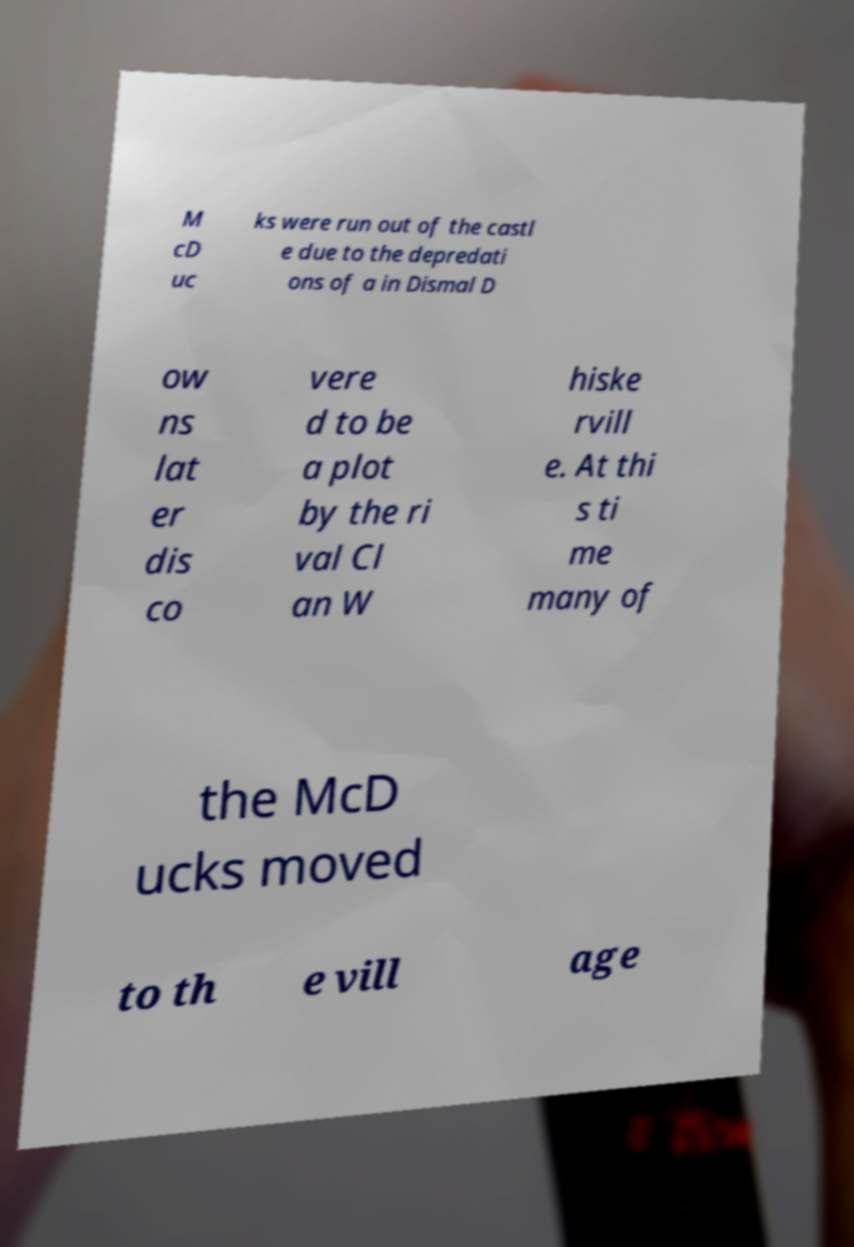I need the written content from this picture converted into text. Can you do that? M cD uc ks were run out of the castl e due to the depredati ons of a in Dismal D ow ns lat er dis co vere d to be a plot by the ri val Cl an W hiske rvill e. At thi s ti me many of the McD ucks moved to th e vill age 